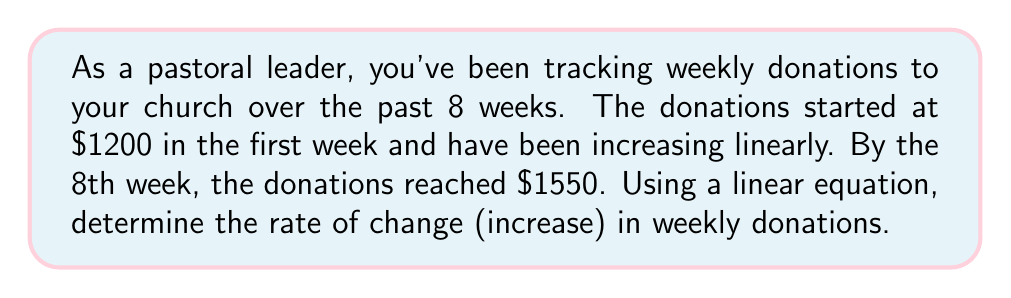Teach me how to tackle this problem. To solve this problem, we'll use the point-slope form of a linear equation:

$$ y - y_1 = m(x - x_1) $$

Where:
- $(x_1, y_1)$ is the initial point (week 1, $1200)
- $(x_2, y_2)$ is the final point (week 8, $1550)
- $m$ is the slope, which represents the rate of change

Step 1: Identify the two points:
- Point 1: $(1, 1200)$
- Point 2: $(8, 1550)$

Step 2: Calculate the slope (rate of change) using the slope formula:

$$ m = \frac{y_2 - y_1}{x_2 - x_1} = \frac{1550 - 1200}{8 - 1} = \frac{350}{7} = 50 $$

Step 3: Verify the result by plugging it into the point-slope form:

$$ y - 1200 = 50(x - 1) $$

Simplifying:

$$ y = 50x + 1150 $$

This equation confirms that the weekly donations start at $1150 and increase by $50 each week.
Answer: The rate of change in weekly donations is $50 per week. 